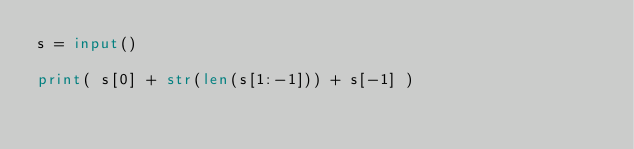<code> <loc_0><loc_0><loc_500><loc_500><_Python_>s = input()

print( s[0] + str(len(s[1:-1])) + s[-1] )
</code> 